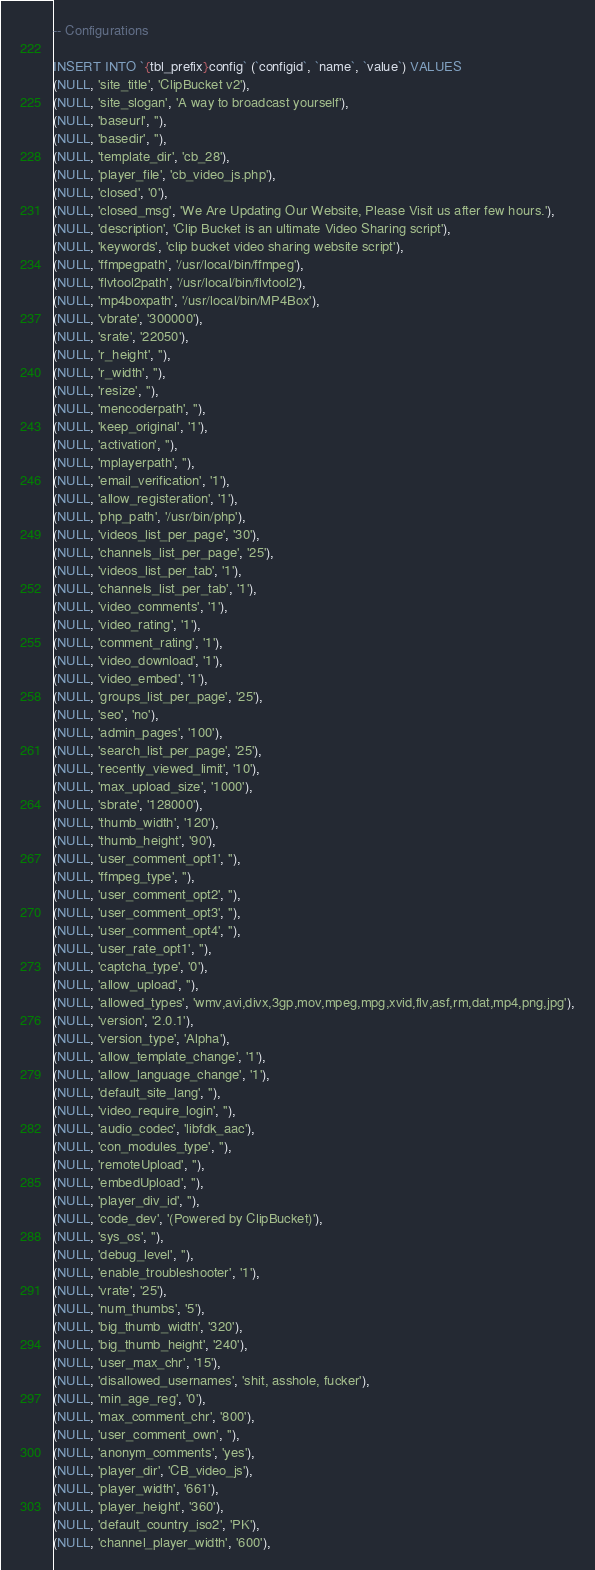Convert code to text. <code><loc_0><loc_0><loc_500><loc_500><_SQL_>-- Configurations

INSERT INTO `{tbl_prefix}config` (`configid`, `name`, `value`) VALUES
(NULL, 'site_title', 'ClipBucket v2'),
(NULL, 'site_slogan', 'A way to broadcast yourself'),
(NULL, 'baseurl', ''),
(NULL, 'basedir', ''),
(NULL, 'template_dir', 'cb_28'),
(NULL, 'player_file', 'cb_video_js.php'),
(NULL, 'closed', '0'),
(NULL, 'closed_msg', 'We Are Updating Our Website, Please Visit us after few hours.'),
(NULL, 'description', 'Clip Bucket is an ultimate Video Sharing script'),
(NULL, 'keywords', 'clip bucket video sharing website script'),
(NULL, 'ffmpegpath', '/usr/local/bin/ffmpeg'),
(NULL, 'flvtool2path', '/usr/local/bin/flvtool2'),
(NULL, 'mp4boxpath', '/usr/local/bin/MP4Box'),
(NULL, 'vbrate', '300000'),
(NULL, 'srate', '22050'),
(NULL, 'r_height', ''),
(NULL, 'r_width', ''),
(NULL, 'resize', ''),
(NULL, 'mencoderpath', ''),
(NULL, 'keep_original', '1'),
(NULL, 'activation', ''),
(NULL, 'mplayerpath', ''),
(NULL, 'email_verification', '1'),
(NULL, 'allow_registeration', '1'),
(NULL, 'php_path', '/usr/bin/php'),
(NULL, 'videos_list_per_page', '30'),
(NULL, 'channels_list_per_page', '25'),
(NULL, 'videos_list_per_tab', '1'),
(NULL, 'channels_list_per_tab', '1'),
(NULL, 'video_comments', '1'),
(NULL, 'video_rating', '1'),
(NULL, 'comment_rating', '1'),
(NULL, 'video_download', '1'),
(NULL, 'video_embed', '1'),
(NULL, 'groups_list_per_page', '25'),
(NULL, 'seo', 'no'),
(NULL, 'admin_pages', '100'),
(NULL, 'search_list_per_page', '25'),
(NULL, 'recently_viewed_limit', '10'),
(NULL, 'max_upload_size', '1000'),
(NULL, 'sbrate', '128000'),
(NULL, 'thumb_width', '120'),
(NULL, 'thumb_height', '90'),
(NULL, 'user_comment_opt1', ''),
(NULL, 'ffmpeg_type', ''),
(NULL, 'user_comment_opt2', ''),
(NULL, 'user_comment_opt3', ''),
(NULL, 'user_comment_opt4', ''),
(NULL, 'user_rate_opt1', ''),
(NULL, 'captcha_type', '0'),
(NULL, 'allow_upload', ''),
(NULL, 'allowed_types', 'wmv,avi,divx,3gp,mov,mpeg,mpg,xvid,flv,asf,rm,dat,mp4,png,jpg'),
(NULL, 'version', '2.0.1'),
(NULL, 'version_type', 'Alpha'),
(NULL, 'allow_template_change', '1'),
(NULL, 'allow_language_change', '1'),
(NULL, 'default_site_lang', ''),
(NULL, 'video_require_login', ''),
(NULL, 'audio_codec', 'libfdk_aac'),
(NULL, 'con_modules_type', ''),
(NULL, 'remoteUpload', ''),
(NULL, 'embedUpload', ''),
(NULL, 'player_div_id', ''),
(NULL, 'code_dev', '(Powered by ClipBucket)'),
(NULL, 'sys_os', ''),
(NULL, 'debug_level', ''),
(NULL, 'enable_troubleshooter', '1'),
(NULL, 'vrate', '25'),
(NULL, 'num_thumbs', '5'),
(NULL, 'big_thumb_width', '320'),
(NULL, 'big_thumb_height', '240'),
(NULL, 'user_max_chr', '15'),
(NULL, 'disallowed_usernames', 'shit, asshole, fucker'),
(NULL, 'min_age_reg', '0'),
(NULL, 'max_comment_chr', '800'),
(NULL, 'user_comment_own', ''),
(NULL, 'anonym_comments', 'yes'),
(NULL, 'player_dir', 'CB_video_js'),
(NULL, 'player_width', '661'),
(NULL, 'player_height', '360'),
(NULL, 'default_country_iso2', 'PK'),
(NULL, 'channel_player_width', '600'),</code> 